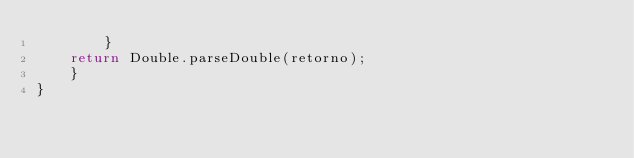Convert code to text. <code><loc_0><loc_0><loc_500><loc_500><_Java_>        }
    return Double.parseDouble(retorno);
    }
}
</code> 